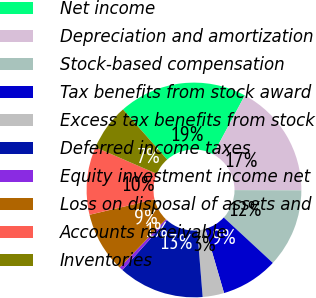Convert chart. <chart><loc_0><loc_0><loc_500><loc_500><pie_chart><fcel>Net income<fcel>Depreciation and amortization<fcel>Stock-based compensation<fcel>Tax benefits from stock award<fcel>Excess tax benefits from stock<fcel>Deferred income taxes<fcel>Equity investment income net<fcel>Loss on disposal of assets and<fcel>Accounts receivable<fcel>Inventories<nl><fcel>19.35%<fcel>17.2%<fcel>11.83%<fcel>8.6%<fcel>3.23%<fcel>12.9%<fcel>0.54%<fcel>9.14%<fcel>10.22%<fcel>6.99%<nl></chart> 